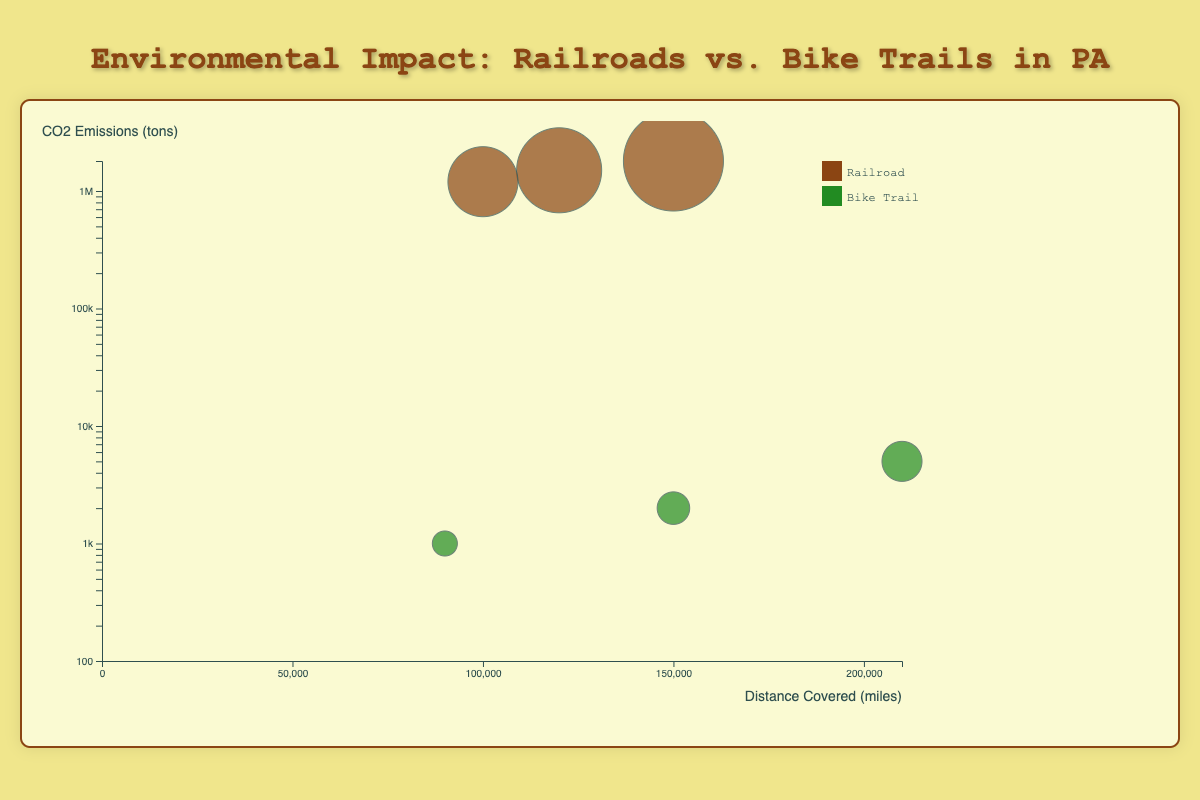What is the title of the chart? The title of the chart is usually found at the top of the figure, providing a summary of what the data represents. Here, it reads "Environmental Impact: Railroads vs. Bike Trails in PA".
Answer: Environmental Impact: Railroads vs. Bike Trails in PA What do the x and y axes represent? The x-axis represents the "Distance Covered (miles)" while the y-axis represents "CO2 Emissions (tons)". These labels are typically found along the side and bottom of the chart.
Answer: Distance Covered (miles) and CO2 Emissions (tons) What color represents bike trails on the chart? The legend on the chart shows the color coding, with bike trails represented in green.
Answer: Green Which railroad entity has the highest CO2 emissions? By examining the sizes and positions of the circles representing railroads, CSX Transportation, with its CO2 emissions at 1,800,000 tons, appears highest on the y-axis.
Answer: CSX Transportation How many bike trails are represented on the chart? We can count the distinct data points corresponding to bike trails, identified by green circles. There are three: Heritage Rail Trail County Park, Great Allegheny Passage, and Montour Trail.
Answer: Three Which bike trail covers the most distance? The circles representing bike trails can be compared along the x-axis to find the one that covers the most distance. Heritage Rail Trail County Park, at 210,000 miles, is furthest right.
Answer: Heritage Rail Trail County Park What is the total CO2 emissions of all railroads combined? Summing the CO2 emissions of all railroads: Norfolk Southern Corporation (1,500,000) + CSX Transportation (1,800,000) + Reading Blue Mountain and Northern Railroad (1,200,000). The total is 1,500,000 + 1,800,000 + 1,200,000 = 4,500,000 tons.
Answer: 4,500,000 tons Which entity has the smallest circle and what does it represent? The smallest circle, representing entities with the least passengers or users, belongs to Montour Trail. This can be identified by the circle size on the plot.
Answer: Montour Trail Do bike trails or railroads generally emit less CO2 per mile covered? By comparing the general position of the green and brown circles along the y-axis, bike trails mostly fall lower than railroads in terms of CO2 emissions per distance covered.
Answer: Bike trails Which entity has the highest number of users? The entity with the largest circle size (representing the highest number of users) among bike trails is Heritage Rail Trail County Park, which has 200,000 users.
Answer: Heritage Rail Trail County Park 